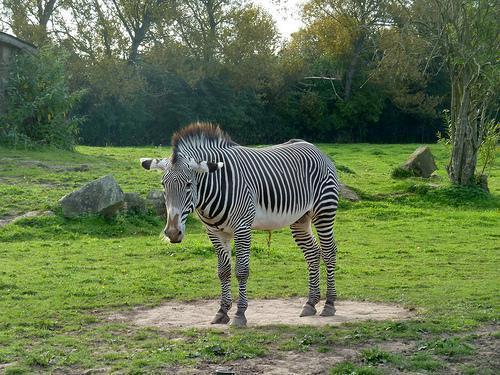How many zebras are there?
Give a very brief answer. 1. 